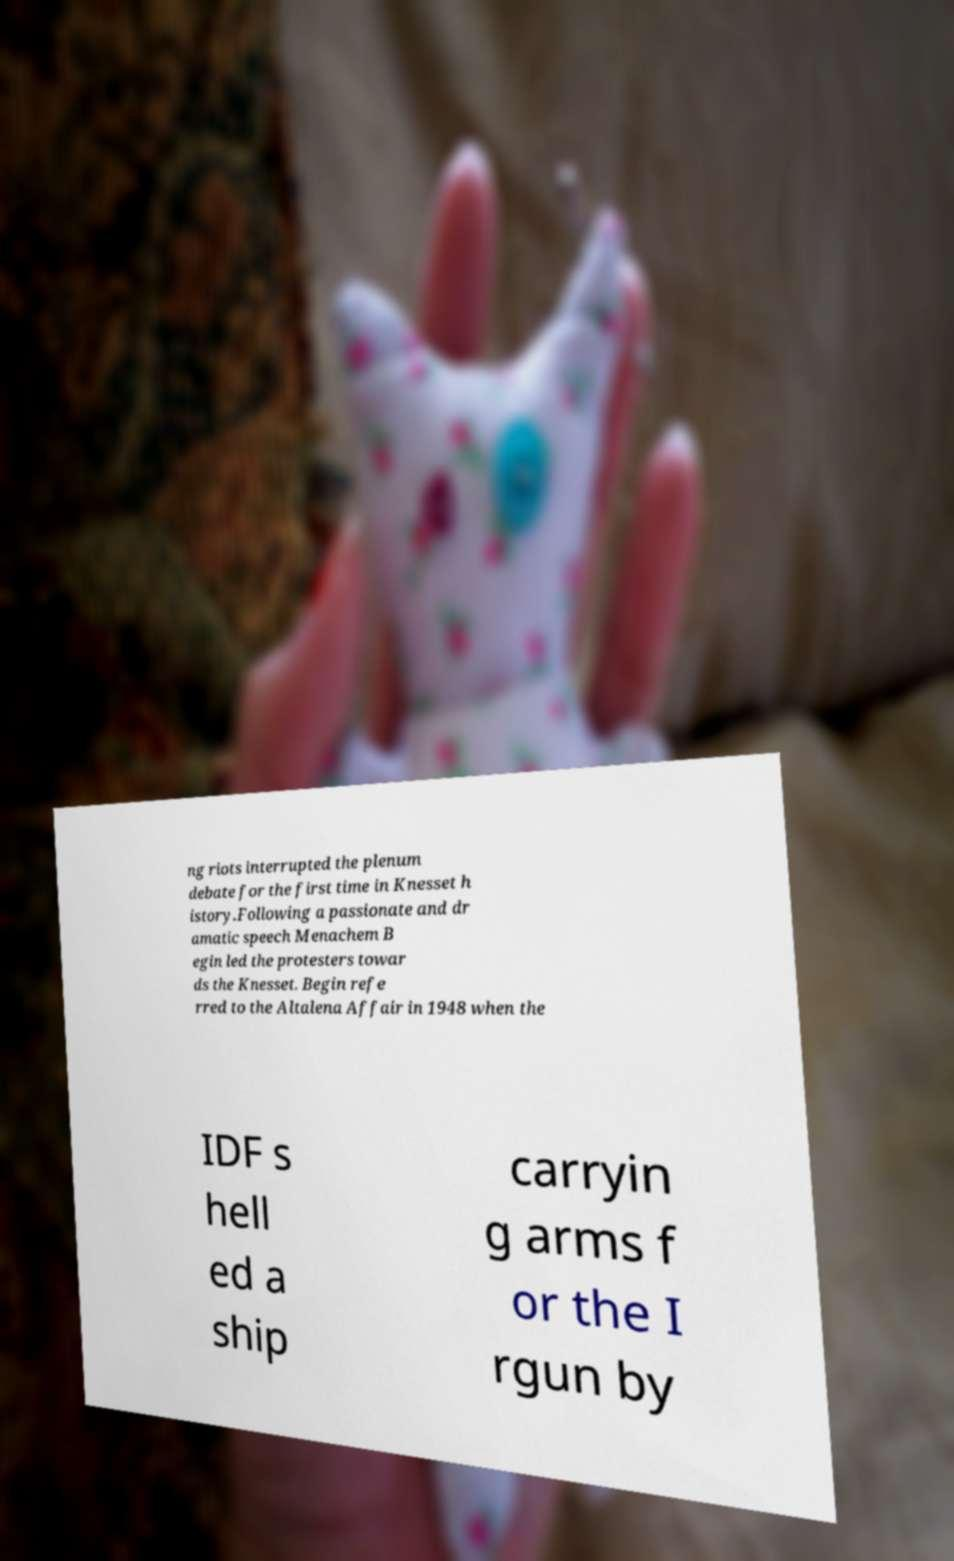Could you assist in decoding the text presented in this image and type it out clearly? ng riots interrupted the plenum debate for the first time in Knesset h istory.Following a passionate and dr amatic speech Menachem B egin led the protesters towar ds the Knesset. Begin refe rred to the Altalena Affair in 1948 when the IDF s hell ed a ship carryin g arms f or the I rgun by 